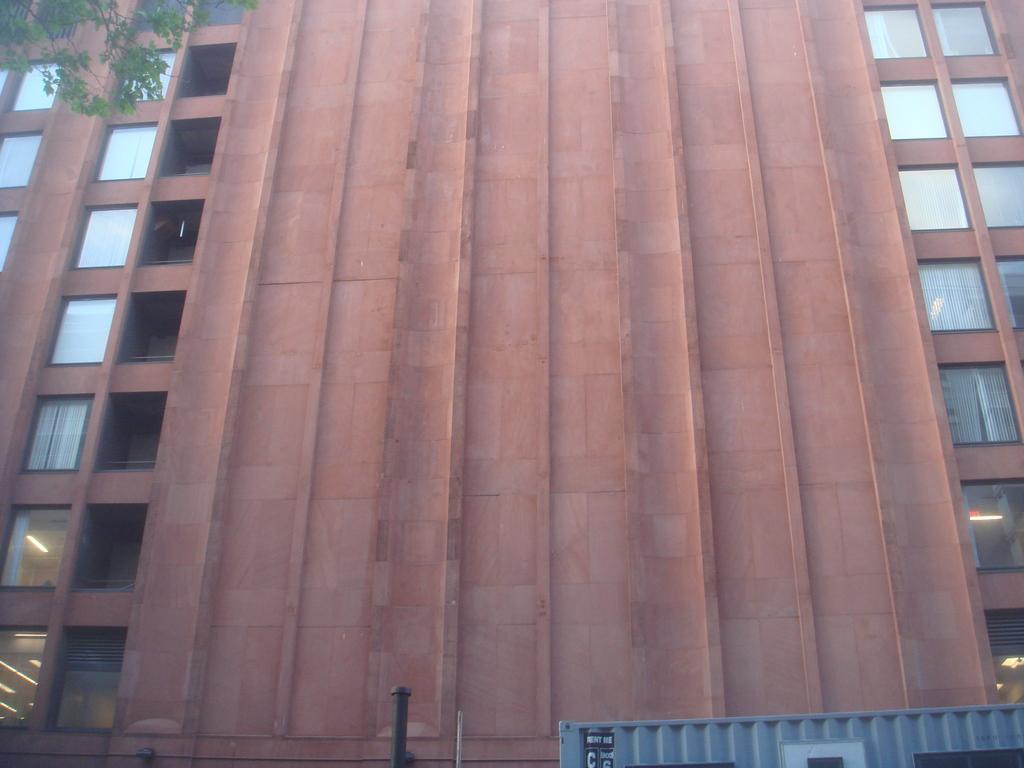Can you describe this image briefly? In this image I can see a building in brown color and a tree in green color. 